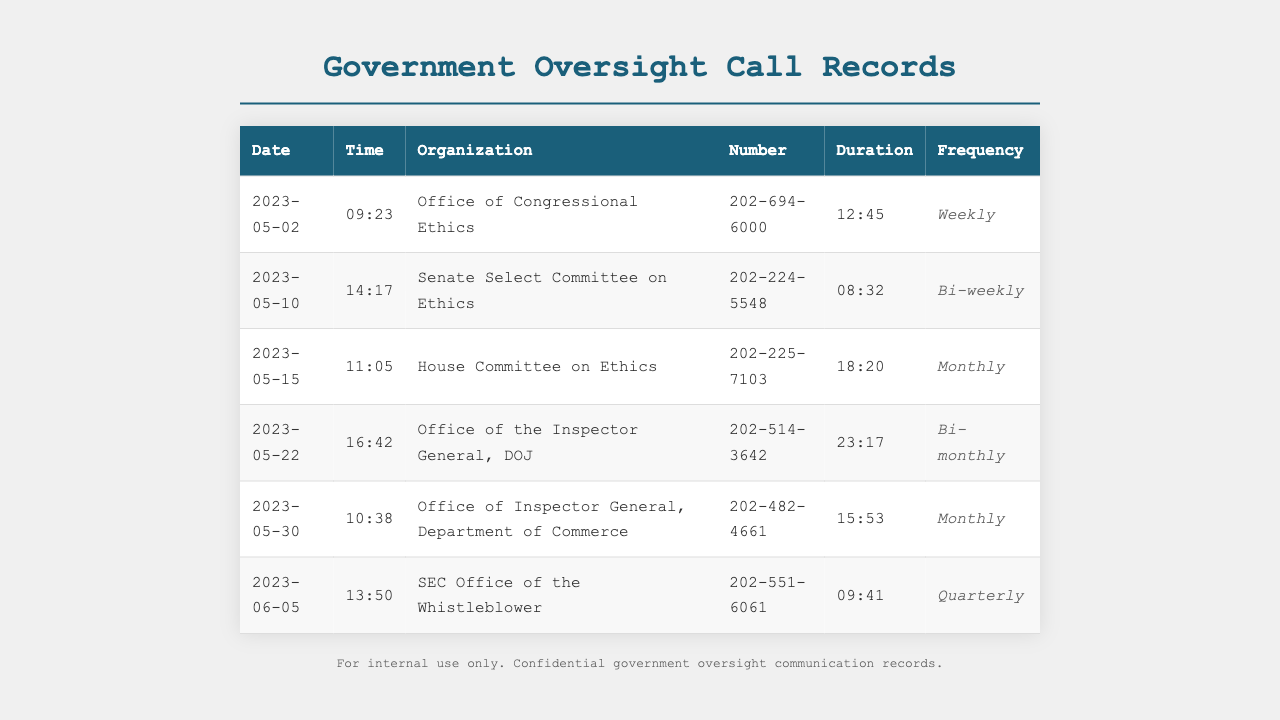What is the longest call duration recorded? The longest call duration is found in the row for the Office of the Inspector General, DOJ, which lasts for 23 minutes and 17 seconds.
Answer: 23:17 How many times is the House Committee on Ethics contacted? The frequency of contact for the House Committee on Ethics is mentioned as Monthly, indicating it is contacted once a month.
Answer: Monthly Which organization has the frequency labeled as Quarterly? The organization listed with a Quarterly frequency is the SEC Office of the Whistleblower, as noted in the document.
Answer: SEC Office of the Whistleblower What is the date of the first recorded call? The first recorded call is on May 2, 2023, which is the earliest date present in the document.
Answer: 2023-05-02 How many different organizations are contacted in total? Counting each distinct organization listed in the table provides the total of 6 different organizations.
Answer: 6 What is the total duration of calls made to the Office of Congressional Ethics? The total duration for calls made to this organization is noted as 12 minutes and 45 seconds.
Answer: 12:45 Which organization's contact number starts with 202-225? The contact number starting with 202-225 belongs to the House Committee on Ethics, as stated in the call records.
Answer: House Committee on Ethics What day of the week is the second call noted in the document? The second call in the document occurs on May 10, 2023, which is a Wednesday.
Answer: Wednesday 